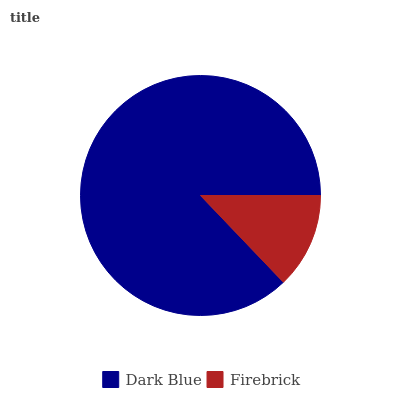Is Firebrick the minimum?
Answer yes or no. Yes. Is Dark Blue the maximum?
Answer yes or no. Yes. Is Firebrick the maximum?
Answer yes or no. No. Is Dark Blue greater than Firebrick?
Answer yes or no. Yes. Is Firebrick less than Dark Blue?
Answer yes or no. Yes. Is Firebrick greater than Dark Blue?
Answer yes or no. No. Is Dark Blue less than Firebrick?
Answer yes or no. No. Is Dark Blue the high median?
Answer yes or no. Yes. Is Firebrick the low median?
Answer yes or no. Yes. Is Firebrick the high median?
Answer yes or no. No. Is Dark Blue the low median?
Answer yes or no. No. 